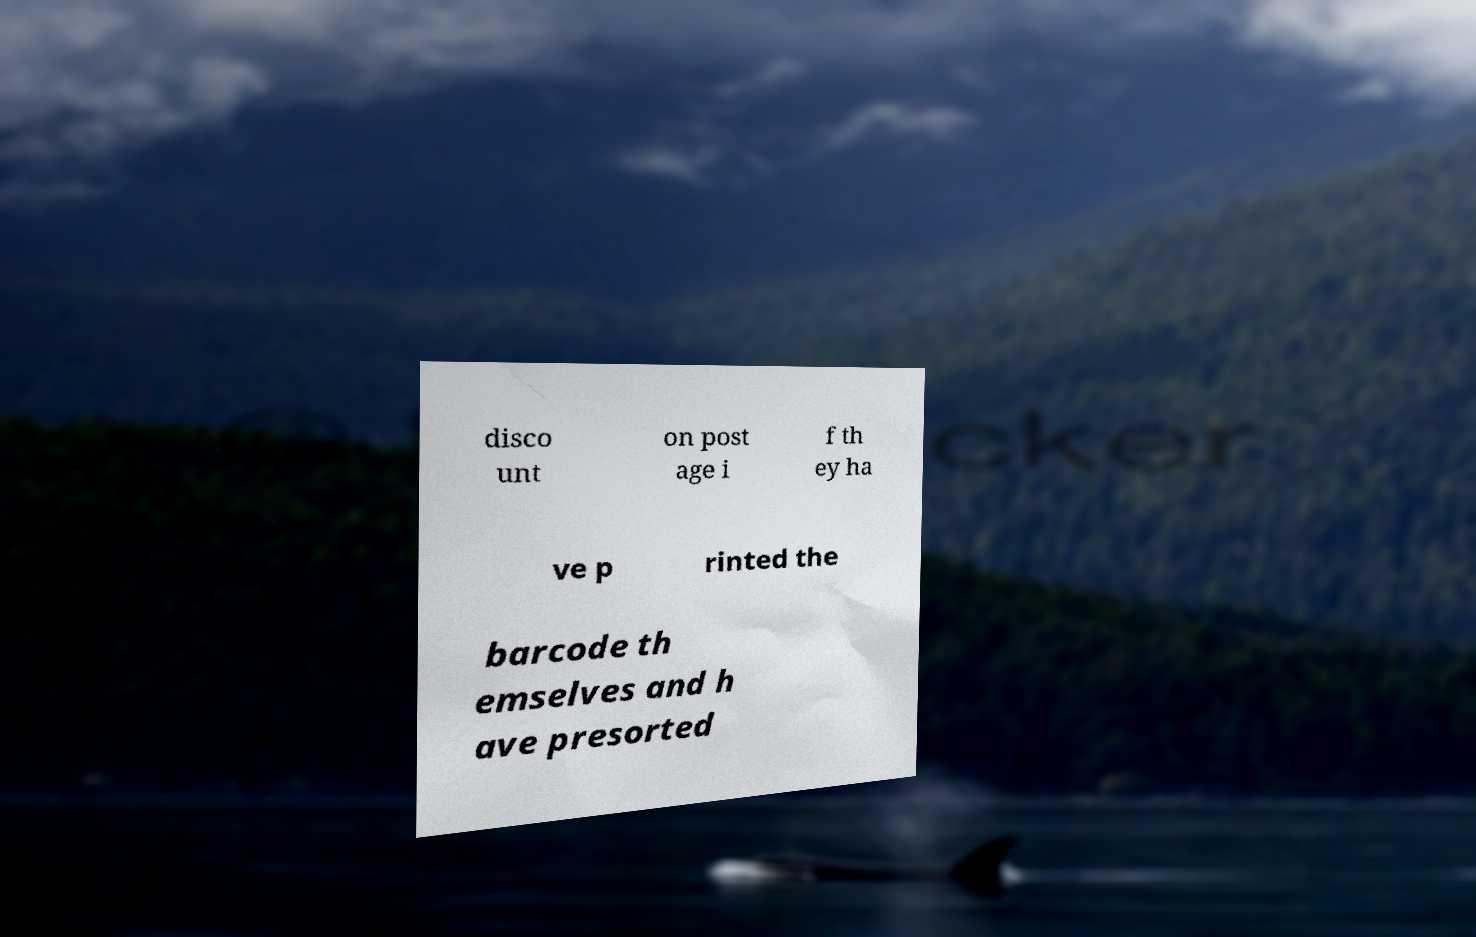What messages or text are displayed in this image? I need them in a readable, typed format. disco unt on post age i f th ey ha ve p rinted the barcode th emselves and h ave presorted 